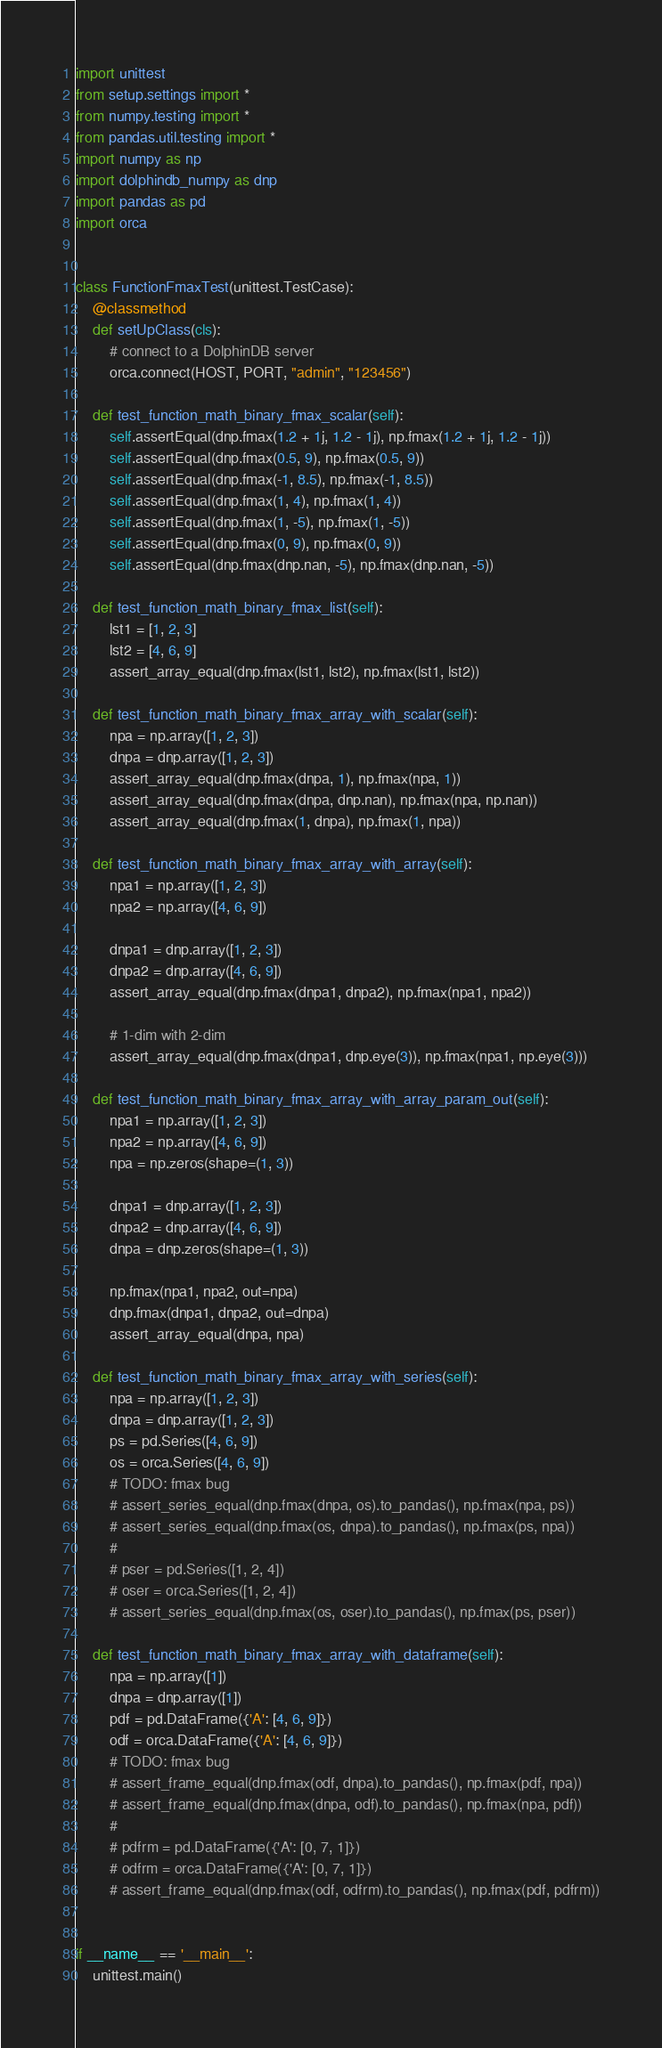Convert code to text. <code><loc_0><loc_0><loc_500><loc_500><_Python_>import unittest
from setup.settings import *
from numpy.testing import *
from pandas.util.testing import *
import numpy as np
import dolphindb_numpy as dnp
import pandas as pd
import orca


class FunctionFmaxTest(unittest.TestCase):
    @classmethod
    def setUpClass(cls):
        # connect to a DolphinDB server
        orca.connect(HOST, PORT, "admin", "123456")

    def test_function_math_binary_fmax_scalar(self):
        self.assertEqual(dnp.fmax(1.2 + 1j, 1.2 - 1j), np.fmax(1.2 + 1j, 1.2 - 1j))
        self.assertEqual(dnp.fmax(0.5, 9), np.fmax(0.5, 9))
        self.assertEqual(dnp.fmax(-1, 8.5), np.fmax(-1, 8.5))
        self.assertEqual(dnp.fmax(1, 4), np.fmax(1, 4))
        self.assertEqual(dnp.fmax(1, -5), np.fmax(1, -5))
        self.assertEqual(dnp.fmax(0, 9), np.fmax(0, 9))
        self.assertEqual(dnp.fmax(dnp.nan, -5), np.fmax(dnp.nan, -5))

    def test_function_math_binary_fmax_list(self):
        lst1 = [1, 2, 3]
        lst2 = [4, 6, 9]
        assert_array_equal(dnp.fmax(lst1, lst2), np.fmax(lst1, lst2))

    def test_function_math_binary_fmax_array_with_scalar(self):
        npa = np.array([1, 2, 3])
        dnpa = dnp.array([1, 2, 3])
        assert_array_equal(dnp.fmax(dnpa, 1), np.fmax(npa, 1))
        assert_array_equal(dnp.fmax(dnpa, dnp.nan), np.fmax(npa, np.nan))
        assert_array_equal(dnp.fmax(1, dnpa), np.fmax(1, npa))

    def test_function_math_binary_fmax_array_with_array(self):
        npa1 = np.array([1, 2, 3])
        npa2 = np.array([4, 6, 9])

        dnpa1 = dnp.array([1, 2, 3])
        dnpa2 = dnp.array([4, 6, 9])
        assert_array_equal(dnp.fmax(dnpa1, dnpa2), np.fmax(npa1, npa2))

        # 1-dim with 2-dim
        assert_array_equal(dnp.fmax(dnpa1, dnp.eye(3)), np.fmax(npa1, np.eye(3)))

    def test_function_math_binary_fmax_array_with_array_param_out(self):
        npa1 = np.array([1, 2, 3])
        npa2 = np.array([4, 6, 9])
        npa = np.zeros(shape=(1, 3))

        dnpa1 = dnp.array([1, 2, 3])
        dnpa2 = dnp.array([4, 6, 9])
        dnpa = dnp.zeros(shape=(1, 3))

        np.fmax(npa1, npa2, out=npa)
        dnp.fmax(dnpa1, dnpa2, out=dnpa)
        assert_array_equal(dnpa, npa)

    def test_function_math_binary_fmax_array_with_series(self):
        npa = np.array([1, 2, 3])
        dnpa = dnp.array([1, 2, 3])
        ps = pd.Series([4, 6, 9])
        os = orca.Series([4, 6, 9])
        # TODO: fmax bug
        # assert_series_equal(dnp.fmax(dnpa, os).to_pandas(), np.fmax(npa, ps))
        # assert_series_equal(dnp.fmax(os, dnpa).to_pandas(), np.fmax(ps, npa))
        #
        # pser = pd.Series([1, 2, 4])
        # oser = orca.Series([1, 2, 4])
        # assert_series_equal(dnp.fmax(os, oser).to_pandas(), np.fmax(ps, pser))

    def test_function_math_binary_fmax_array_with_dataframe(self):
        npa = np.array([1])
        dnpa = dnp.array([1])
        pdf = pd.DataFrame({'A': [4, 6, 9]})
        odf = orca.DataFrame({'A': [4, 6, 9]})
        # TODO: fmax bug
        # assert_frame_equal(dnp.fmax(odf, dnpa).to_pandas(), np.fmax(pdf, npa))
        # assert_frame_equal(dnp.fmax(dnpa, odf).to_pandas(), np.fmax(npa, pdf))
        #
        # pdfrm = pd.DataFrame({'A': [0, 7, 1]})
        # odfrm = orca.DataFrame({'A': [0, 7, 1]})
        # assert_frame_equal(dnp.fmax(odf, odfrm).to_pandas(), np.fmax(pdf, pdfrm))


if __name__ == '__main__':
    unittest.main()
</code> 